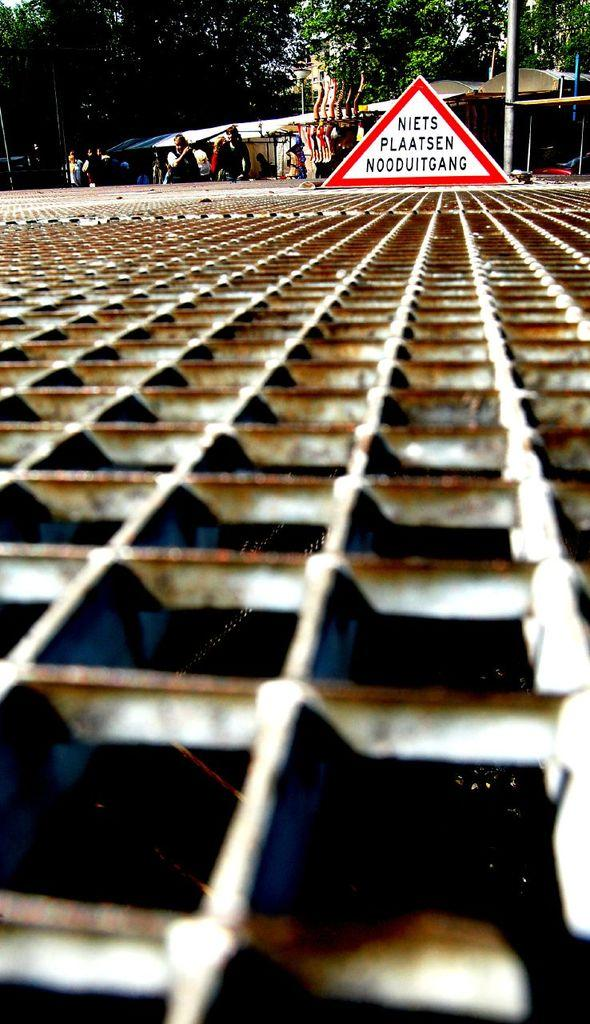What is the main object in the foreground of the image? There is a grille in the image. What is located near the grille? There is a board in the image. What can be seen in the background of the image? There are people, poles, sheds, and trees in the background of the image. How many snakes are slithering on the dock in the image? There are no snakes or dock present in the image. 